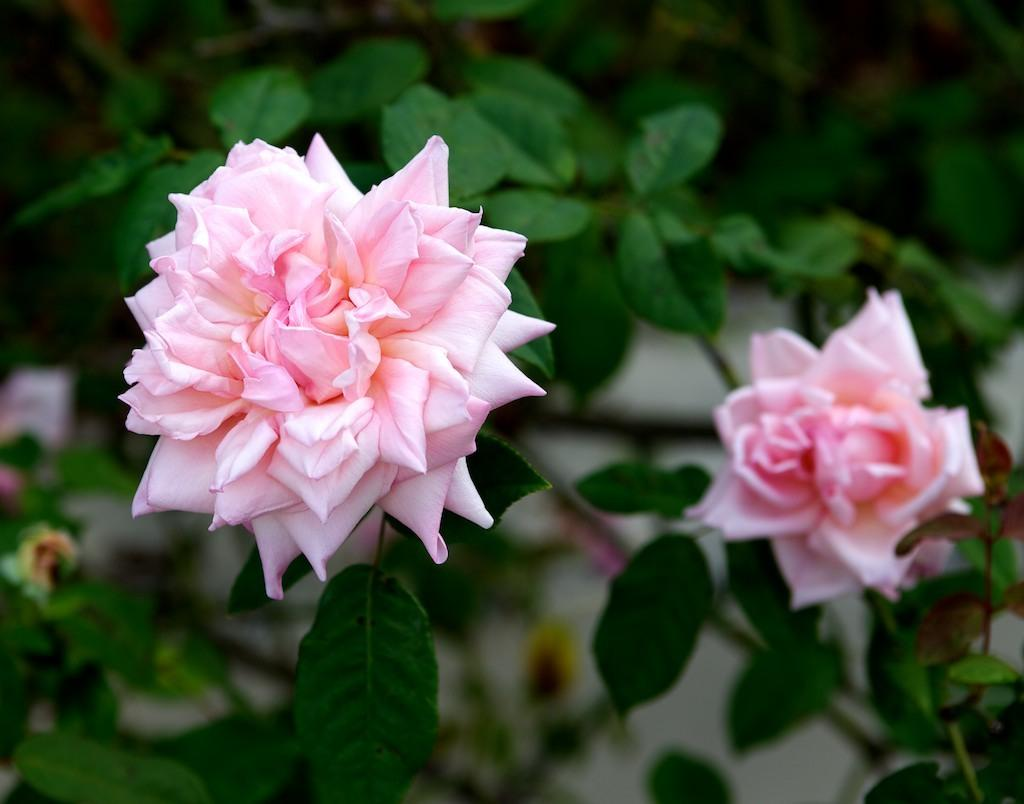What type of flowers are in the image? There are light pink rose flowers in the image. Where are the flowers located? The flowers are on a plant. What can be seen in the background of the image? There is a wall visible in the background of the image. What type of crow is sitting on the jar in the image? There is no crow or jar present in the image; it only features light pink rose flowers on a plant with a wall in the background. 